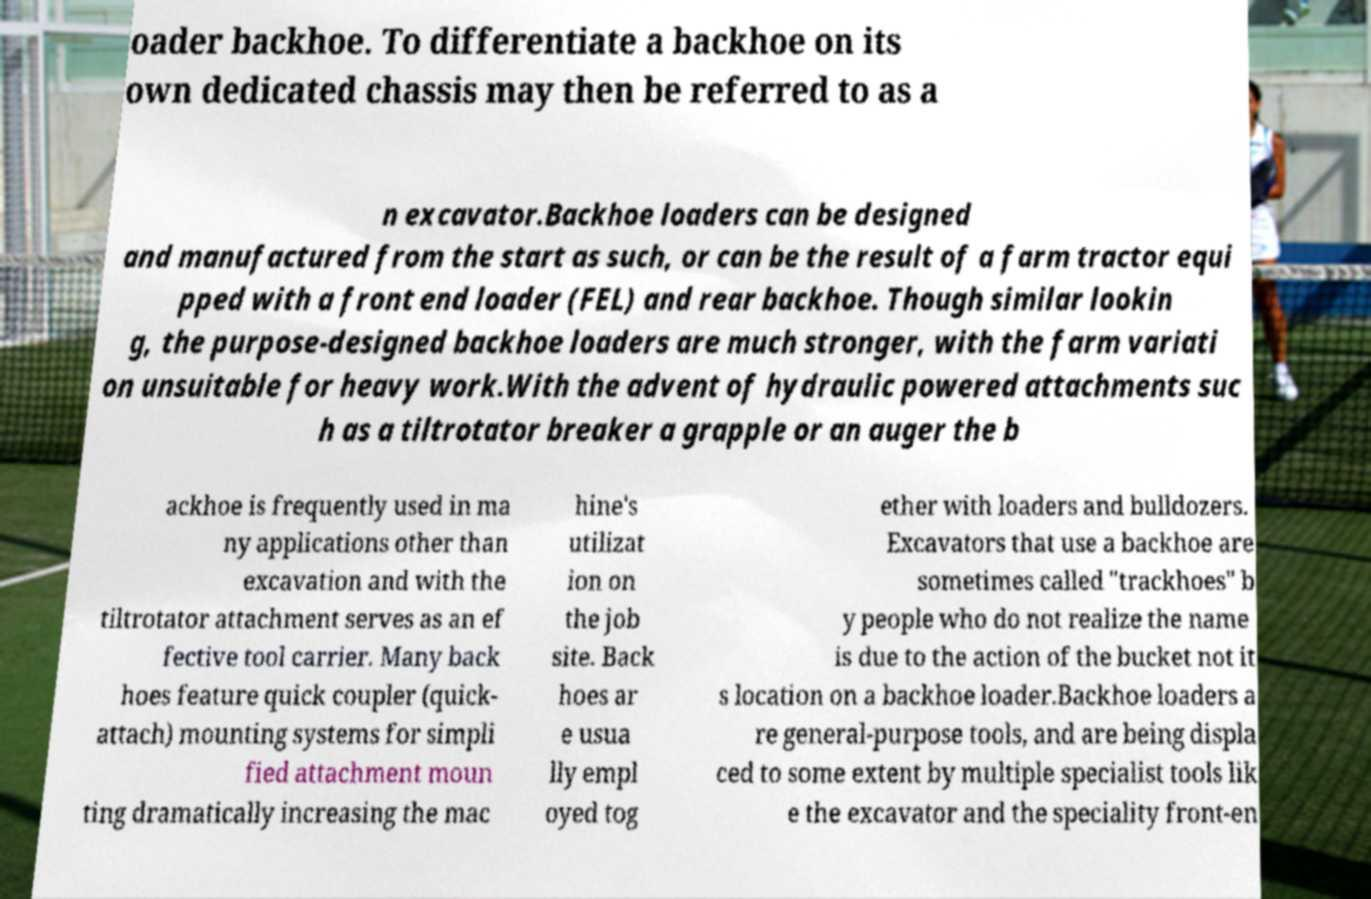Please read and relay the text visible in this image. What does it say? oader backhoe. To differentiate a backhoe on its own dedicated chassis may then be referred to as a n excavator.Backhoe loaders can be designed and manufactured from the start as such, or can be the result of a farm tractor equi pped with a front end loader (FEL) and rear backhoe. Though similar lookin g, the purpose-designed backhoe loaders are much stronger, with the farm variati on unsuitable for heavy work.With the advent of hydraulic powered attachments suc h as a tiltrotator breaker a grapple or an auger the b ackhoe is frequently used in ma ny applications other than excavation and with the tiltrotator attachment serves as an ef fective tool carrier. Many back hoes feature quick coupler (quick- attach) mounting systems for simpli fied attachment moun ting dramatically increasing the mac hine's utilizat ion on the job site. Back hoes ar e usua lly empl oyed tog ether with loaders and bulldozers. Excavators that use a backhoe are sometimes called "trackhoes" b y people who do not realize the name is due to the action of the bucket not it s location on a backhoe loader.Backhoe loaders a re general-purpose tools, and are being displa ced to some extent by multiple specialist tools lik e the excavator and the speciality front-en 